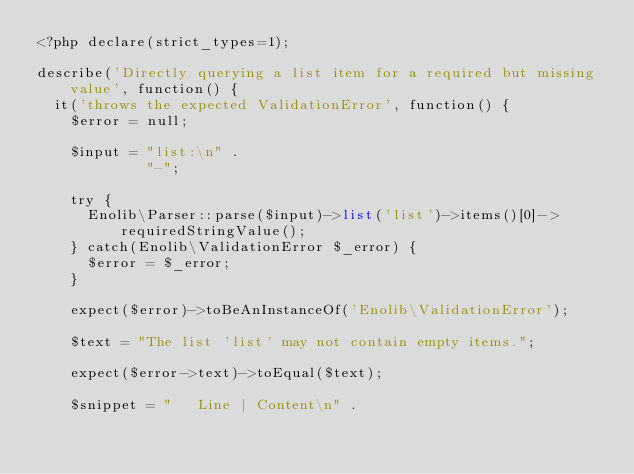<code> <loc_0><loc_0><loc_500><loc_500><_PHP_><?php declare(strict_types=1);

describe('Directly querying a list item for a required but missing value', function() {
  it('throws the expected ValidationError', function() {
    $error = null;

    $input = "list:\n" .
             "-";

    try {
      Enolib\Parser::parse($input)->list('list')->items()[0]->requiredStringValue();
    } catch(Enolib\ValidationError $_error) {
      $error = $_error;
    }

    expect($error)->toBeAnInstanceOf('Enolib\ValidationError');
    
    $text = "The list 'list' may not contain empty items.";
    
    expect($error->text)->toEqual($text);
    
    $snippet = "   Line | Content\n" .</code> 